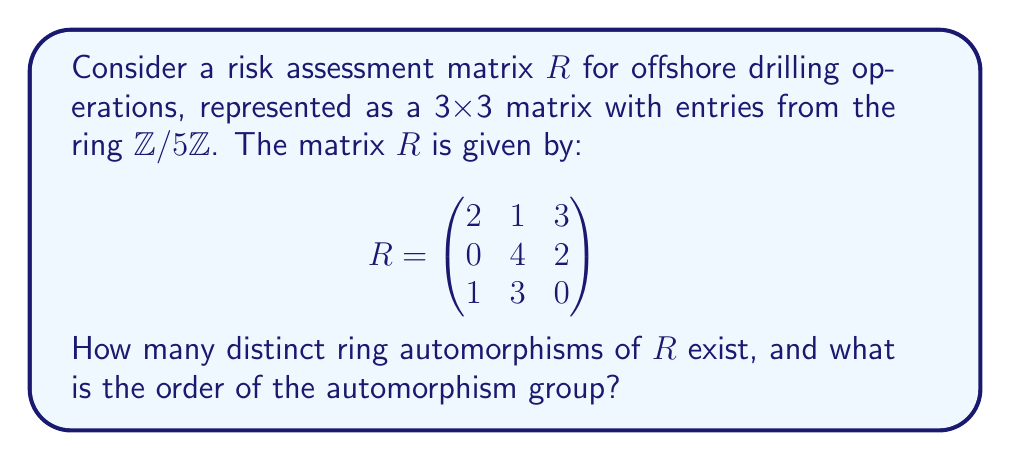What is the answer to this math problem? To solve this problem, we need to follow these steps:

1) First, recall that a ring automorphism of a matrix ring preserves both addition and multiplication, and maps the identity element to itself.

2) In this case, we're working with matrices over $\mathbb{Z}/5\mathbb{Z}$, so our automorphisms must preserve the structure of this field.

3) The automorphisms of $\mathbb{Z}/5\mathbb{Z}$ are precisely the elements of its multiplicative group $(\mathbb{Z}/5\mathbb{Z})^*$, which has order $\phi(5) = 4$.

4) These automorphisms are:
   $f_1(x) = x$ (identity)
   $f_2(x) = 2x$
   $f_3(x) = 3x$
   $f_4(x) = 4x$

5) Each of these automorphisms can be applied element-wise to the matrix $R$ to produce a valid ring automorphism of $R$.

6) Therefore, the number of distinct ring automorphisms of $R$ is equal to the number of automorphisms of $\mathbb{Z}/5\mathbb{Z}$, which is 4.

7) The set of these automorphisms forms a group under composition. This group is isomorphic to $(\mathbb{Z}/5\mathbb{Z})^*$, which is a cyclic group of order 4.

Therefore, there are 4 distinct ring automorphisms of $R$, and the order of the automorphism group is also 4.
Answer: There are 4 distinct ring automorphisms of $R$, and the order of the automorphism group is 4. 